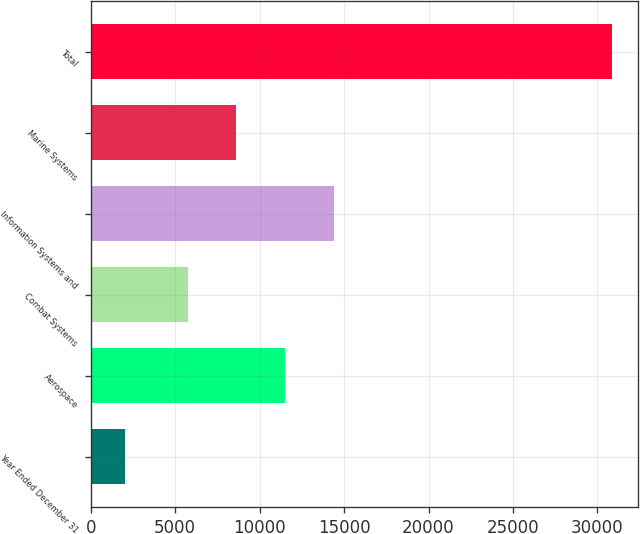Convert chart. <chart><loc_0><loc_0><loc_500><loc_500><bar_chart><fcel>Year Ended December 31<fcel>Aerospace<fcel>Combat Systems<fcel>Information Systems and<fcel>Marine Systems<fcel>Total<nl><fcel>2014<fcel>11499.6<fcel>5732<fcel>14383.4<fcel>8615.8<fcel>30852<nl></chart> 